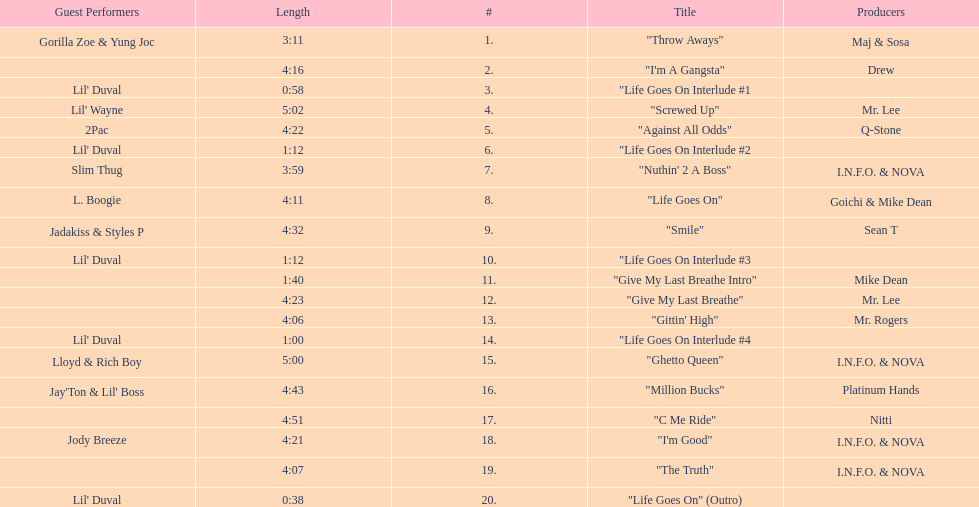Which tracks feature the same producer(s) in consecutive order on this album? "I'm Good", "The Truth". 